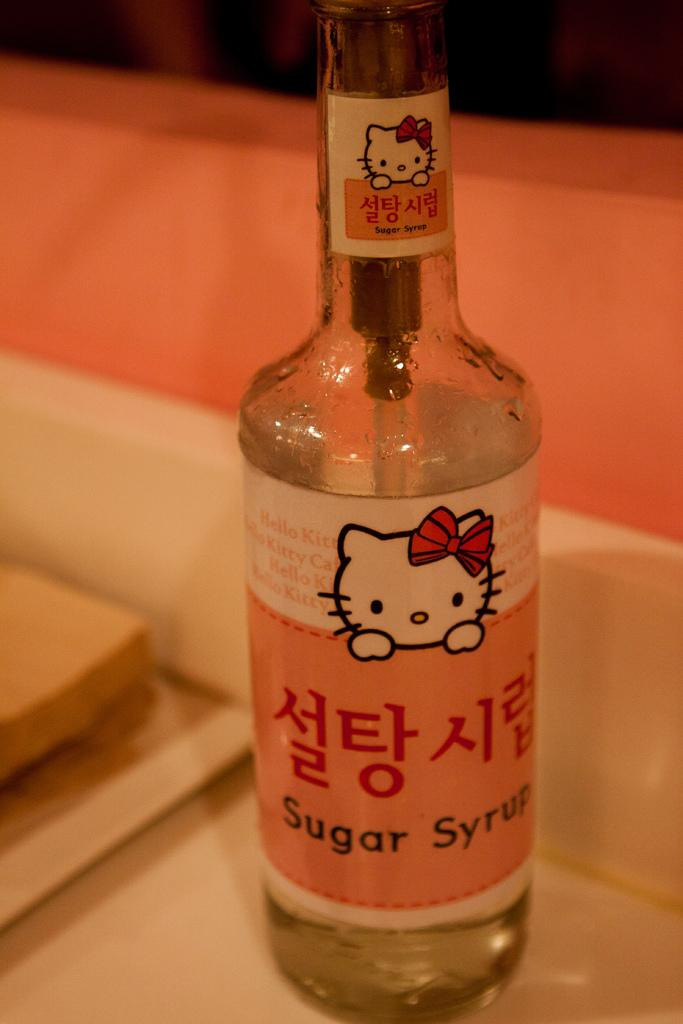<image>
Offer a succinct explanation of the picture presented. A clear bottle of sugar syrup with a Hello Kitty label and Asian writing. 